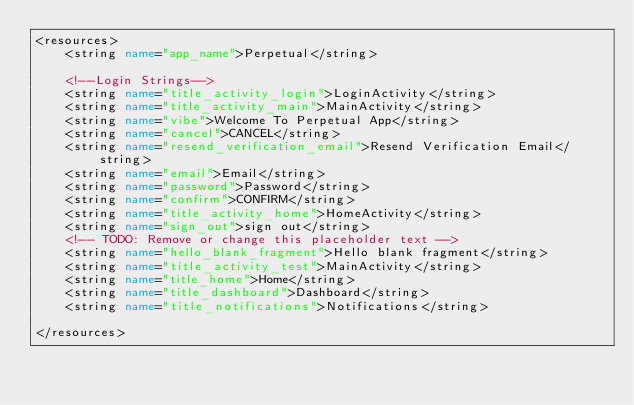Convert code to text. <code><loc_0><loc_0><loc_500><loc_500><_XML_><resources>
    <string name="app_name">Perpetual</string>

    <!--Login Strings-->
    <string name="title_activity_login">LoginActivity</string>
    <string name="title_activity_main">MainActivity</string>
    <string name="vibe">Welcome To Perpetual App</string>
    <string name="cancel">CANCEL</string>
    <string name="resend_verification_email">Resend Verification Email</string>
    <string name="email">Email</string>
    <string name="password">Password</string>
    <string name="confirm">CONFIRM</string>
    <string name="title_activity_home">HomeActivity</string>
    <string name="sign_out">sign out</string>
    <!-- TODO: Remove or change this placeholder text -->
    <string name="hello_blank_fragment">Hello blank fragment</string>
    <string name="title_activity_test">MainActivity</string>
    <string name="title_home">Home</string>
    <string name="title_dashboard">Dashboard</string>
    <string name="title_notifications">Notifications</string>

</resources></code> 